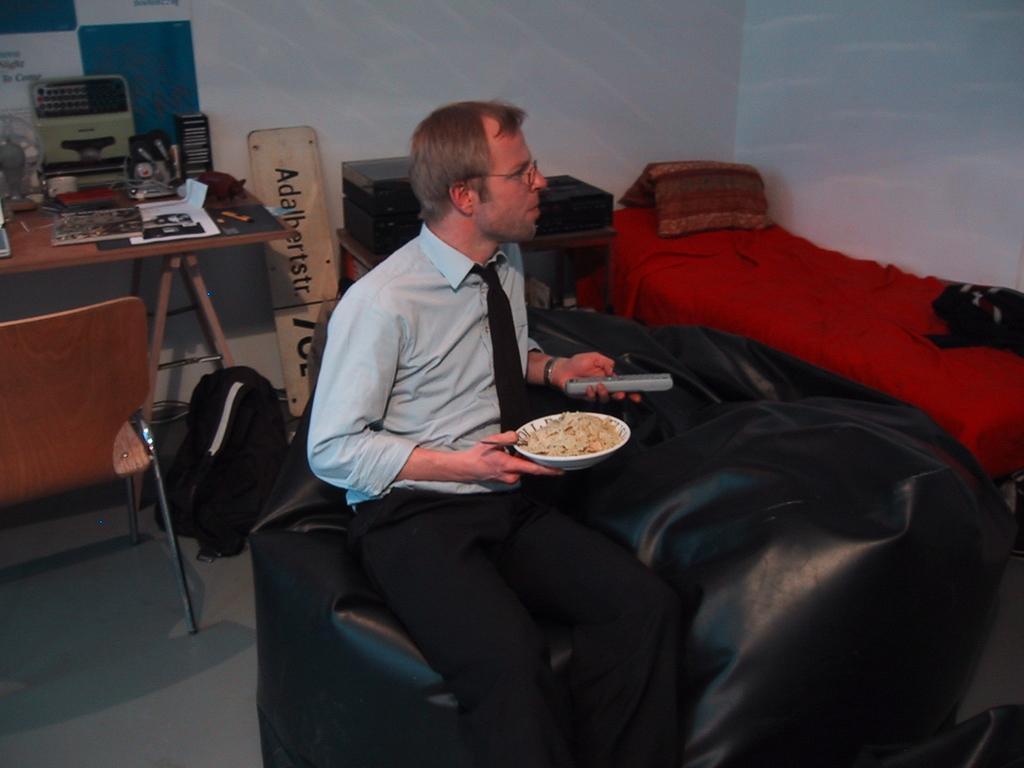Can you describe this image briefly? In this image I see a man who is sitting on a couch and holding a bowl of food and a remote in his hands. In the background I see a bed, a chair, a table on which there are few things and the wall. 